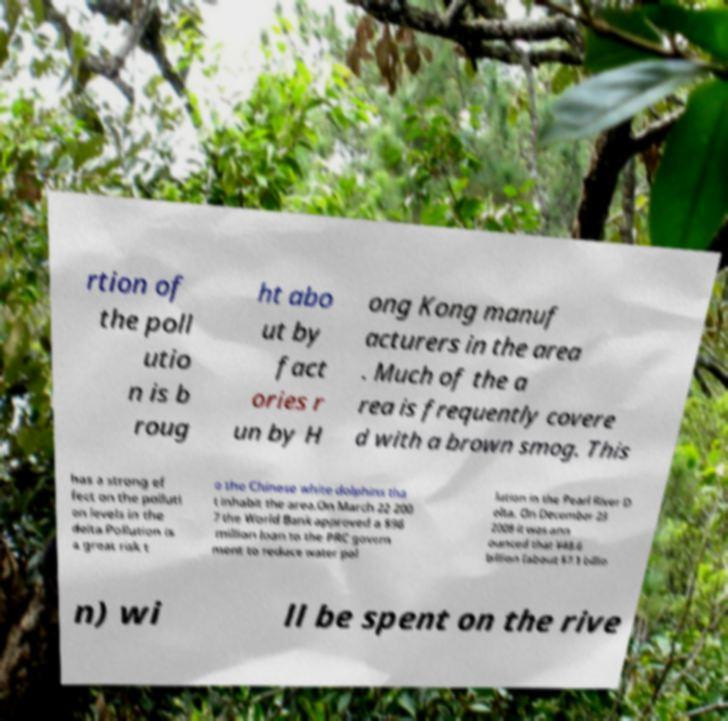Please read and relay the text visible in this image. What does it say? rtion of the poll utio n is b roug ht abo ut by fact ories r un by H ong Kong manuf acturers in the area . Much of the a rea is frequently covere d with a brown smog. This has a strong ef fect on the polluti on levels in the delta.Pollution is a great risk t o the Chinese white dolphins tha t inhabit the area.On March 22 200 7 the World Bank approved a $96 million loan to the PRC govern ment to reduce water pol lution in the Pearl River D elta. On December 23 2008 it was ann ounced that ¥48.6 billion (about $7.1 billio n) wi ll be spent on the rive 